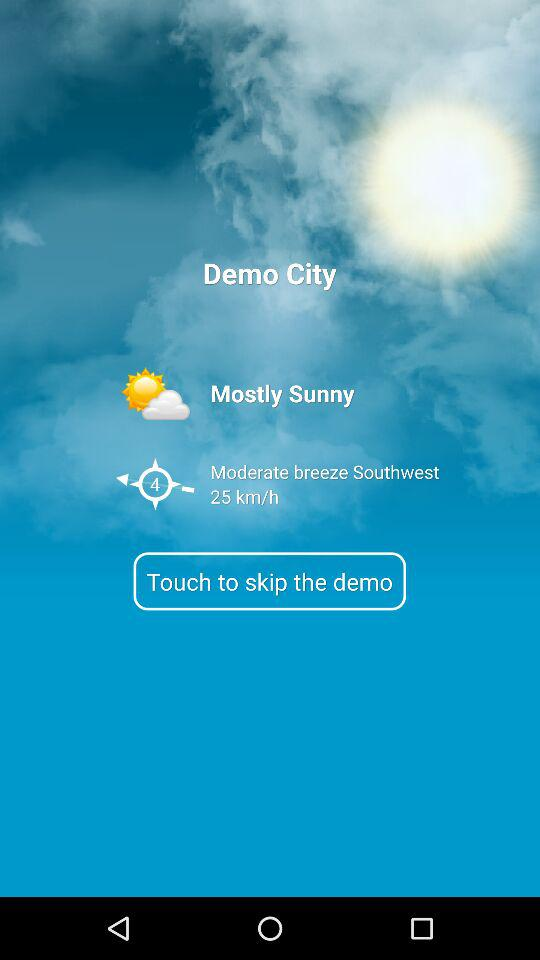What's the weather like in Demo City? The weather is mostly sunny. 